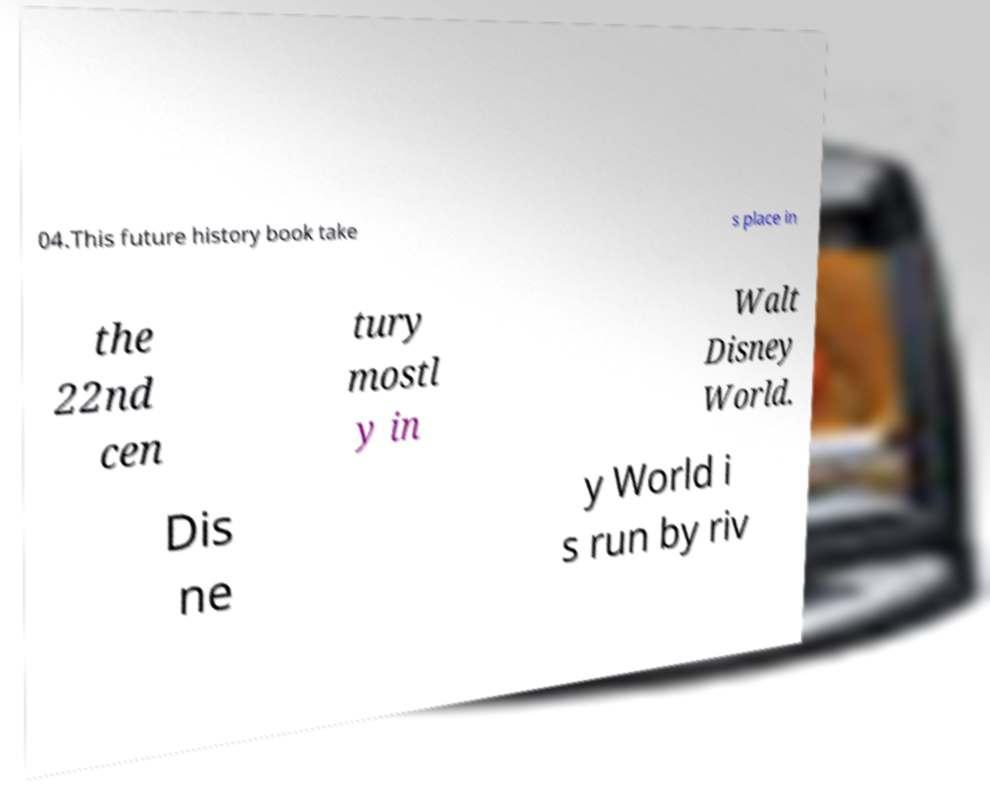For documentation purposes, I need the text within this image transcribed. Could you provide that? 04.This future history book take s place in the 22nd cen tury mostl y in Walt Disney World. Dis ne y World i s run by riv 